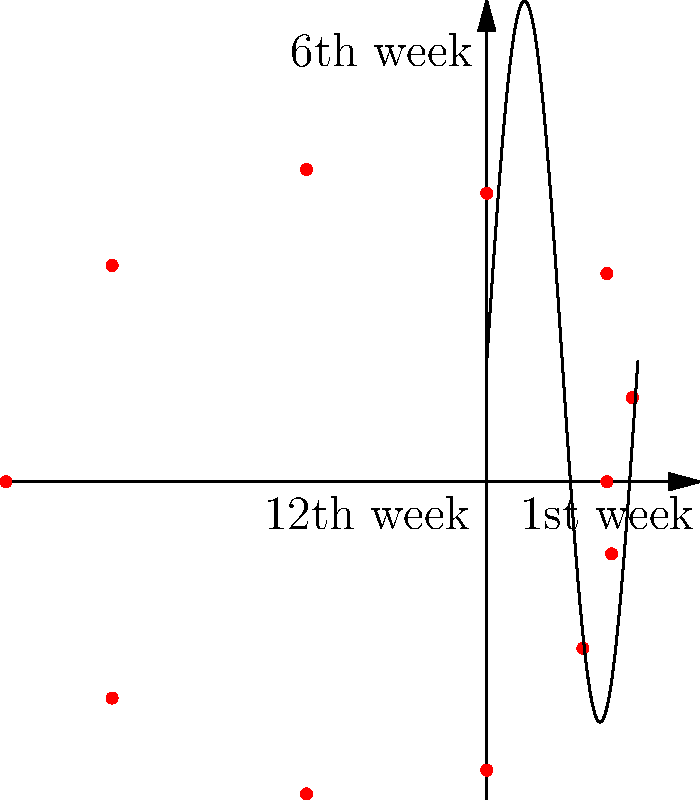In the polar coordinate plot depicting the box office performance of the classic Turkish film "Bir Zamanlar Anadolu'da" over 12 weeks, which week marks the peak of its commercial success, and how does this align with the typical trajectory of art-house films in the Turkish market? To answer this question, we need to analyze the polar coordinate plot and interpret it in the context of Turkish cinema:

1. The plot shows the box office performance over 12 weeks, with each point representing a week.
2. The radial distance from the center represents the box office earnings, while the angular position represents the progression of weeks.
3. To find the peak, we need to identify the point farthest from the center:
   - Week 1 starts at the positive x-axis (3 o'clock position)
   - Moving counterclockwise, we can see the radius increasing
   - The farthest point from the center is at the 6 o'clock position, which corresponds to week 7

4. The peak at week 7 is unusual for typical blockbusters, which often peak in the first or second week.
5. However, for art-house films like "Bir Zamanlar Anadolu'da":
   - They often start slow due to limited release and word-of-mouth marketing
   - Critical acclaim and festival success can lead to expanded distribution
   - This results in a delayed peak, often several weeks into the run

6. The gradual rise and fall in the plot align with the typical trajectory of critically acclaimed Turkish art-house films:
   - Slow start
   - Steady growth as positive reviews spread
   - Peak around mid-run
   - Gradual decline as the film completes its theatrical cycle

7. This pattern contrasts with mainstream commercial Turkish films, which typically have a strong opening but a shorter overall run.

Thus, the peak at week 7 is consistent with the trajectory of successful art-house films in the Turkish market, showcasing the film's critical success translating into commercial performance over time.
Answer: Week 7; aligns with typical art-house film trajectory in Turkish cinema 